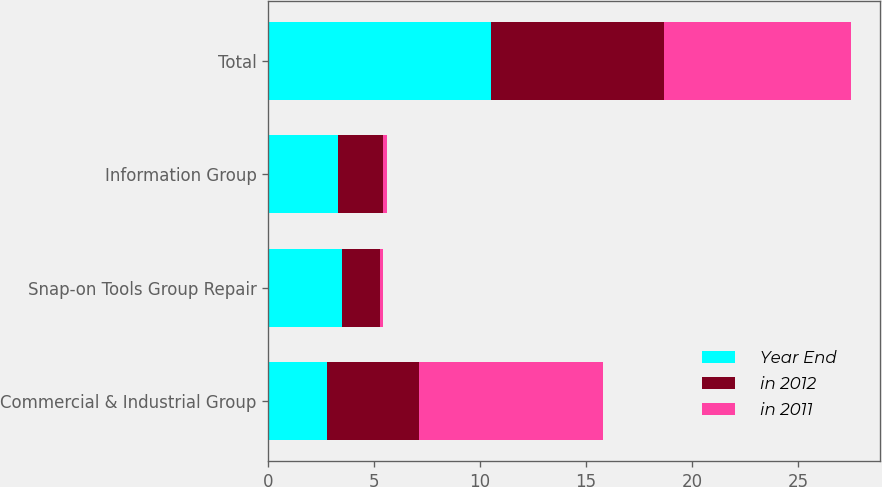Convert chart. <chart><loc_0><loc_0><loc_500><loc_500><stacked_bar_chart><ecel><fcel>Commercial & Industrial Group<fcel>Snap-on Tools Group Repair<fcel>Information Group<fcel>Total<nl><fcel>Year End<fcel>2.8<fcel>3.5<fcel>3.3<fcel>10.5<nl><fcel>in 2012<fcel>4.3<fcel>1.8<fcel>2.1<fcel>8.2<nl><fcel>in 2011<fcel>8.7<fcel>0.1<fcel>0.2<fcel>8.8<nl></chart> 